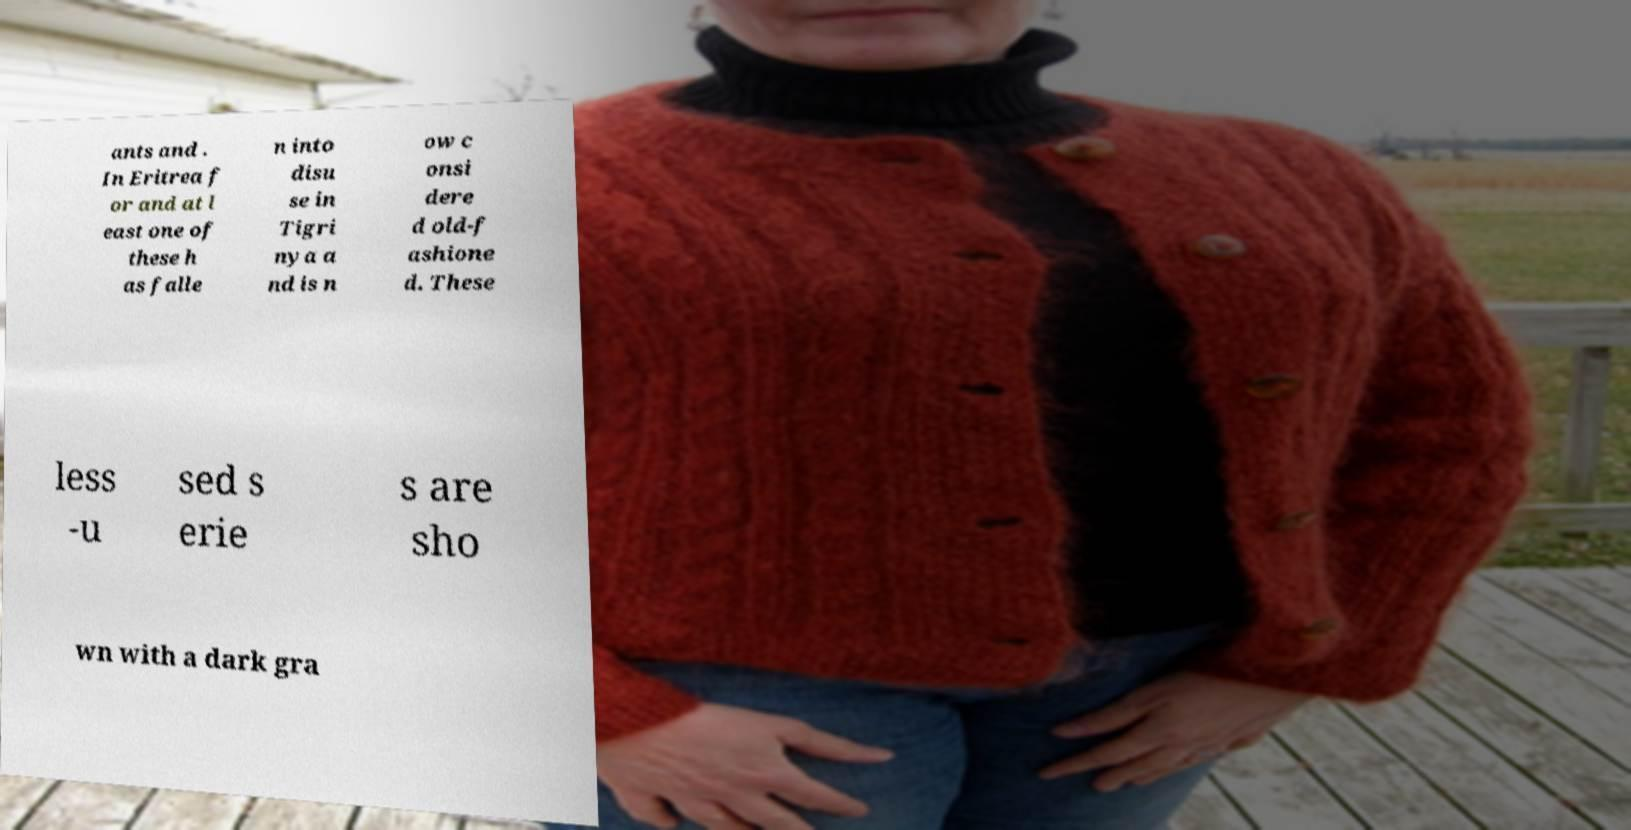What messages or text are displayed in this image? I need them in a readable, typed format. ants and . In Eritrea f or and at l east one of these h as falle n into disu se in Tigri nya a nd is n ow c onsi dere d old-f ashione d. These less -u sed s erie s are sho wn with a dark gra 